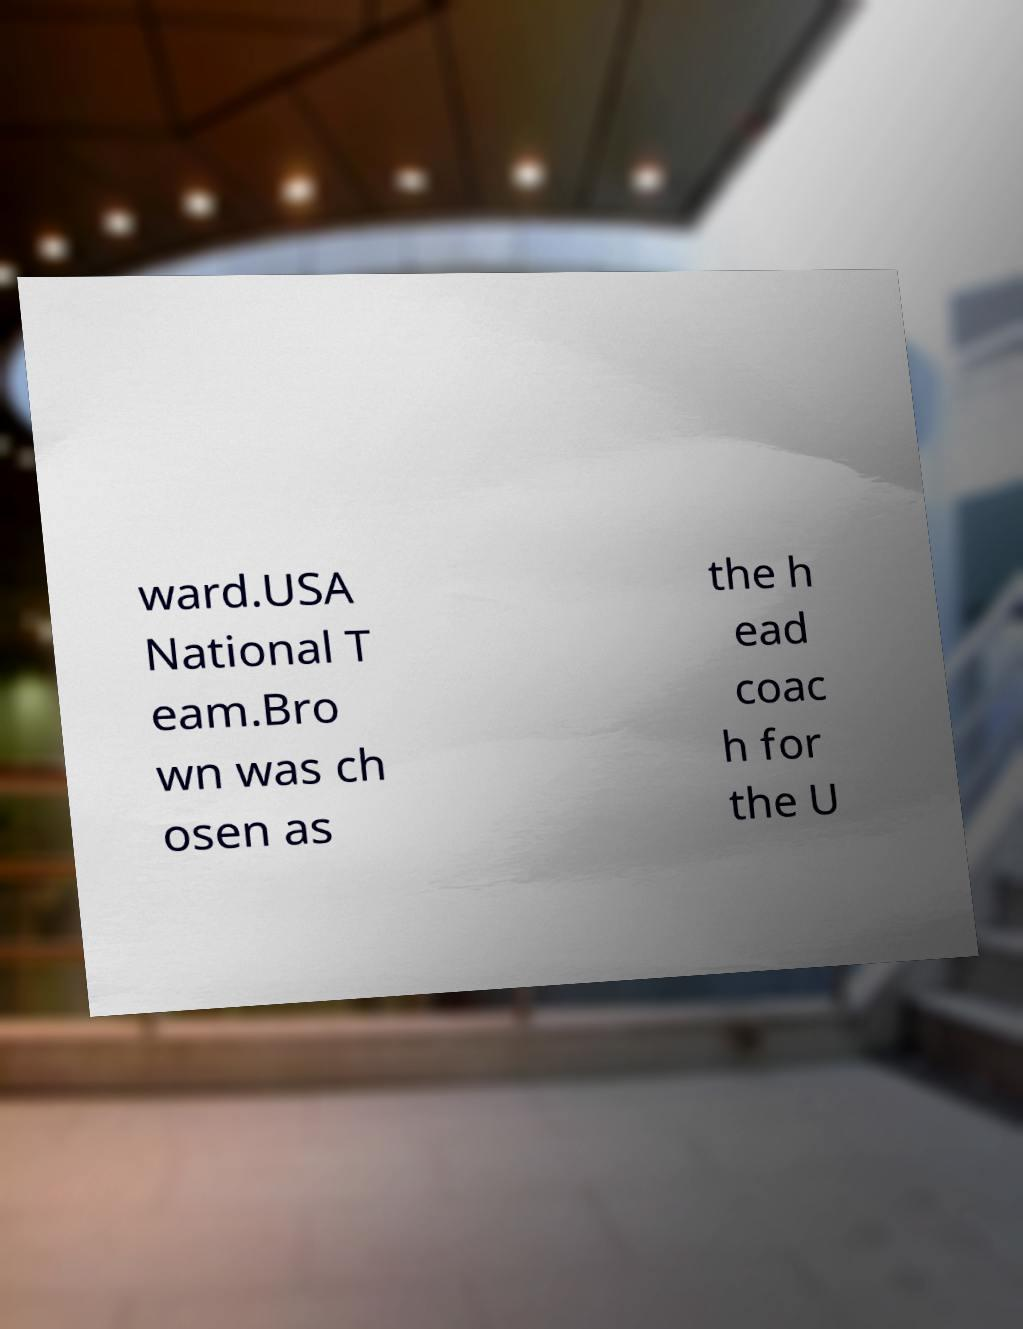I need the written content from this picture converted into text. Can you do that? ward.USA National T eam.Bro wn was ch osen as the h ead coac h for the U 